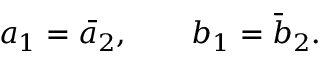Convert formula to latex. <formula><loc_0><loc_0><loc_500><loc_500>a _ { 1 } = \bar { a } _ { 2 } , \quad b _ { 1 } = \bar { b } _ { 2 } .</formula> 